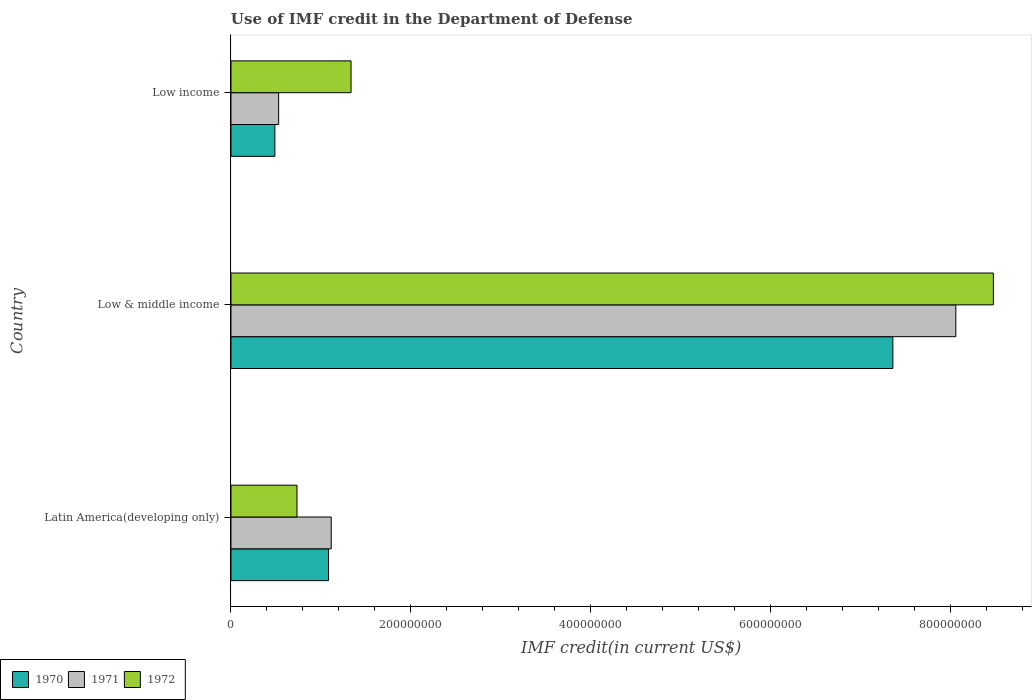How many different coloured bars are there?
Keep it short and to the point. 3. Are the number of bars on each tick of the Y-axis equal?
Provide a succinct answer. Yes. What is the label of the 2nd group of bars from the top?
Offer a very short reply. Low & middle income. In how many cases, is the number of bars for a given country not equal to the number of legend labels?
Your response must be concise. 0. What is the IMF credit in the Department of Defense in 1971 in Low & middle income?
Your response must be concise. 8.06e+08. Across all countries, what is the maximum IMF credit in the Department of Defense in 1972?
Provide a succinct answer. 8.48e+08. Across all countries, what is the minimum IMF credit in the Department of Defense in 1972?
Provide a short and direct response. 7.34e+07. In which country was the IMF credit in the Department of Defense in 1971 maximum?
Your answer should be compact. Low & middle income. In which country was the IMF credit in the Department of Defense in 1971 minimum?
Offer a terse response. Low income. What is the total IMF credit in the Department of Defense in 1971 in the graph?
Keep it short and to the point. 9.71e+08. What is the difference between the IMF credit in the Department of Defense in 1971 in Latin America(developing only) and that in Low income?
Keep it short and to the point. 5.85e+07. What is the difference between the IMF credit in the Department of Defense in 1971 in Latin America(developing only) and the IMF credit in the Department of Defense in 1970 in Low & middle income?
Give a very brief answer. -6.25e+08. What is the average IMF credit in the Department of Defense in 1972 per country?
Ensure brevity in your answer.  3.52e+08. What is the difference between the IMF credit in the Department of Defense in 1971 and IMF credit in the Department of Defense in 1972 in Latin America(developing only)?
Your answer should be compact. 3.81e+07. What is the ratio of the IMF credit in the Department of Defense in 1970 in Low & middle income to that in Low income?
Offer a terse response. 15.08. Is the difference between the IMF credit in the Department of Defense in 1971 in Latin America(developing only) and Low & middle income greater than the difference between the IMF credit in the Department of Defense in 1972 in Latin America(developing only) and Low & middle income?
Make the answer very short. Yes. What is the difference between the highest and the second highest IMF credit in the Department of Defense in 1972?
Your answer should be very brief. 7.14e+08. What is the difference between the highest and the lowest IMF credit in the Department of Defense in 1972?
Your answer should be very brief. 7.75e+08. Is the sum of the IMF credit in the Department of Defense in 1972 in Latin America(developing only) and Low income greater than the maximum IMF credit in the Department of Defense in 1971 across all countries?
Offer a very short reply. No. What does the 2nd bar from the top in Low income represents?
Your response must be concise. 1971. What does the 1st bar from the bottom in Low income represents?
Ensure brevity in your answer.  1970. Is it the case that in every country, the sum of the IMF credit in the Department of Defense in 1972 and IMF credit in the Department of Defense in 1971 is greater than the IMF credit in the Department of Defense in 1970?
Provide a succinct answer. Yes. Are all the bars in the graph horizontal?
Your answer should be very brief. Yes. How many countries are there in the graph?
Offer a very short reply. 3. What is the difference between two consecutive major ticks on the X-axis?
Offer a terse response. 2.00e+08. Are the values on the major ticks of X-axis written in scientific E-notation?
Offer a terse response. No. Does the graph contain any zero values?
Give a very brief answer. No. Does the graph contain grids?
Offer a very short reply. No. How many legend labels are there?
Offer a very short reply. 3. How are the legend labels stacked?
Your response must be concise. Horizontal. What is the title of the graph?
Your response must be concise. Use of IMF credit in the Department of Defense. What is the label or title of the X-axis?
Make the answer very short. IMF credit(in current US$). What is the label or title of the Y-axis?
Offer a very short reply. Country. What is the IMF credit(in current US$) of 1970 in Latin America(developing only)?
Offer a terse response. 1.09e+08. What is the IMF credit(in current US$) in 1971 in Latin America(developing only)?
Your response must be concise. 1.12e+08. What is the IMF credit(in current US$) in 1972 in Latin America(developing only)?
Offer a terse response. 7.34e+07. What is the IMF credit(in current US$) of 1970 in Low & middle income?
Provide a short and direct response. 7.36e+08. What is the IMF credit(in current US$) of 1971 in Low & middle income?
Provide a short and direct response. 8.06e+08. What is the IMF credit(in current US$) in 1972 in Low & middle income?
Offer a very short reply. 8.48e+08. What is the IMF credit(in current US$) in 1970 in Low income?
Give a very brief answer. 4.88e+07. What is the IMF credit(in current US$) of 1971 in Low income?
Your answer should be compact. 5.30e+07. What is the IMF credit(in current US$) of 1972 in Low income?
Ensure brevity in your answer.  1.34e+08. Across all countries, what is the maximum IMF credit(in current US$) of 1970?
Offer a very short reply. 7.36e+08. Across all countries, what is the maximum IMF credit(in current US$) in 1971?
Provide a short and direct response. 8.06e+08. Across all countries, what is the maximum IMF credit(in current US$) of 1972?
Your response must be concise. 8.48e+08. Across all countries, what is the minimum IMF credit(in current US$) in 1970?
Provide a succinct answer. 4.88e+07. Across all countries, what is the minimum IMF credit(in current US$) of 1971?
Provide a succinct answer. 5.30e+07. Across all countries, what is the minimum IMF credit(in current US$) of 1972?
Provide a succinct answer. 7.34e+07. What is the total IMF credit(in current US$) of 1970 in the graph?
Offer a terse response. 8.94e+08. What is the total IMF credit(in current US$) of 1971 in the graph?
Your answer should be very brief. 9.71e+08. What is the total IMF credit(in current US$) in 1972 in the graph?
Give a very brief answer. 1.06e+09. What is the difference between the IMF credit(in current US$) in 1970 in Latin America(developing only) and that in Low & middle income?
Offer a very short reply. -6.28e+08. What is the difference between the IMF credit(in current US$) in 1971 in Latin America(developing only) and that in Low & middle income?
Ensure brevity in your answer.  -6.95e+08. What is the difference between the IMF credit(in current US$) in 1972 in Latin America(developing only) and that in Low & middle income?
Your response must be concise. -7.75e+08. What is the difference between the IMF credit(in current US$) of 1970 in Latin America(developing only) and that in Low income?
Keep it short and to the point. 5.97e+07. What is the difference between the IMF credit(in current US$) of 1971 in Latin America(developing only) and that in Low income?
Give a very brief answer. 5.85e+07. What is the difference between the IMF credit(in current US$) in 1972 in Latin America(developing only) and that in Low income?
Offer a very short reply. -6.01e+07. What is the difference between the IMF credit(in current US$) in 1970 in Low & middle income and that in Low income?
Keep it short and to the point. 6.87e+08. What is the difference between the IMF credit(in current US$) of 1971 in Low & middle income and that in Low income?
Your response must be concise. 7.53e+08. What is the difference between the IMF credit(in current US$) in 1972 in Low & middle income and that in Low income?
Your answer should be very brief. 7.14e+08. What is the difference between the IMF credit(in current US$) of 1970 in Latin America(developing only) and the IMF credit(in current US$) of 1971 in Low & middle income?
Your answer should be very brief. -6.98e+08. What is the difference between the IMF credit(in current US$) in 1970 in Latin America(developing only) and the IMF credit(in current US$) in 1972 in Low & middle income?
Your response must be concise. -7.40e+08. What is the difference between the IMF credit(in current US$) in 1971 in Latin America(developing only) and the IMF credit(in current US$) in 1972 in Low & middle income?
Keep it short and to the point. -7.37e+08. What is the difference between the IMF credit(in current US$) of 1970 in Latin America(developing only) and the IMF credit(in current US$) of 1971 in Low income?
Your answer should be very brief. 5.55e+07. What is the difference between the IMF credit(in current US$) of 1970 in Latin America(developing only) and the IMF credit(in current US$) of 1972 in Low income?
Keep it short and to the point. -2.50e+07. What is the difference between the IMF credit(in current US$) of 1971 in Latin America(developing only) and the IMF credit(in current US$) of 1972 in Low income?
Your answer should be compact. -2.20e+07. What is the difference between the IMF credit(in current US$) of 1970 in Low & middle income and the IMF credit(in current US$) of 1971 in Low income?
Ensure brevity in your answer.  6.83e+08. What is the difference between the IMF credit(in current US$) of 1970 in Low & middle income and the IMF credit(in current US$) of 1972 in Low income?
Your answer should be compact. 6.03e+08. What is the difference between the IMF credit(in current US$) in 1971 in Low & middle income and the IMF credit(in current US$) in 1972 in Low income?
Your answer should be compact. 6.73e+08. What is the average IMF credit(in current US$) of 1970 per country?
Offer a very short reply. 2.98e+08. What is the average IMF credit(in current US$) in 1971 per country?
Offer a terse response. 3.24e+08. What is the average IMF credit(in current US$) of 1972 per country?
Offer a very short reply. 3.52e+08. What is the difference between the IMF credit(in current US$) of 1970 and IMF credit(in current US$) of 1971 in Latin America(developing only)?
Offer a terse response. -3.01e+06. What is the difference between the IMF credit(in current US$) of 1970 and IMF credit(in current US$) of 1972 in Latin America(developing only)?
Offer a very short reply. 3.51e+07. What is the difference between the IMF credit(in current US$) of 1971 and IMF credit(in current US$) of 1972 in Latin America(developing only)?
Keep it short and to the point. 3.81e+07. What is the difference between the IMF credit(in current US$) of 1970 and IMF credit(in current US$) of 1971 in Low & middle income?
Your answer should be very brief. -7.00e+07. What is the difference between the IMF credit(in current US$) of 1970 and IMF credit(in current US$) of 1972 in Low & middle income?
Provide a succinct answer. -1.12e+08. What is the difference between the IMF credit(in current US$) of 1971 and IMF credit(in current US$) of 1972 in Low & middle income?
Your answer should be very brief. -4.18e+07. What is the difference between the IMF credit(in current US$) of 1970 and IMF credit(in current US$) of 1971 in Low income?
Your response must be concise. -4.21e+06. What is the difference between the IMF credit(in current US$) of 1970 and IMF credit(in current US$) of 1972 in Low income?
Offer a terse response. -8.47e+07. What is the difference between the IMF credit(in current US$) of 1971 and IMF credit(in current US$) of 1972 in Low income?
Your response must be concise. -8.05e+07. What is the ratio of the IMF credit(in current US$) in 1970 in Latin America(developing only) to that in Low & middle income?
Give a very brief answer. 0.15. What is the ratio of the IMF credit(in current US$) of 1971 in Latin America(developing only) to that in Low & middle income?
Provide a succinct answer. 0.14. What is the ratio of the IMF credit(in current US$) of 1972 in Latin America(developing only) to that in Low & middle income?
Offer a terse response. 0.09. What is the ratio of the IMF credit(in current US$) in 1970 in Latin America(developing only) to that in Low income?
Keep it short and to the point. 2.22. What is the ratio of the IMF credit(in current US$) of 1971 in Latin America(developing only) to that in Low income?
Ensure brevity in your answer.  2.1. What is the ratio of the IMF credit(in current US$) of 1972 in Latin America(developing only) to that in Low income?
Provide a short and direct response. 0.55. What is the ratio of the IMF credit(in current US$) in 1970 in Low & middle income to that in Low income?
Keep it short and to the point. 15.08. What is the ratio of the IMF credit(in current US$) in 1971 in Low & middle income to that in Low income?
Provide a succinct answer. 15.21. What is the ratio of the IMF credit(in current US$) in 1972 in Low & middle income to that in Low income?
Make the answer very short. 6.35. What is the difference between the highest and the second highest IMF credit(in current US$) in 1970?
Your answer should be very brief. 6.28e+08. What is the difference between the highest and the second highest IMF credit(in current US$) in 1971?
Ensure brevity in your answer.  6.95e+08. What is the difference between the highest and the second highest IMF credit(in current US$) in 1972?
Make the answer very short. 7.14e+08. What is the difference between the highest and the lowest IMF credit(in current US$) in 1970?
Provide a succinct answer. 6.87e+08. What is the difference between the highest and the lowest IMF credit(in current US$) of 1971?
Give a very brief answer. 7.53e+08. What is the difference between the highest and the lowest IMF credit(in current US$) of 1972?
Keep it short and to the point. 7.75e+08. 